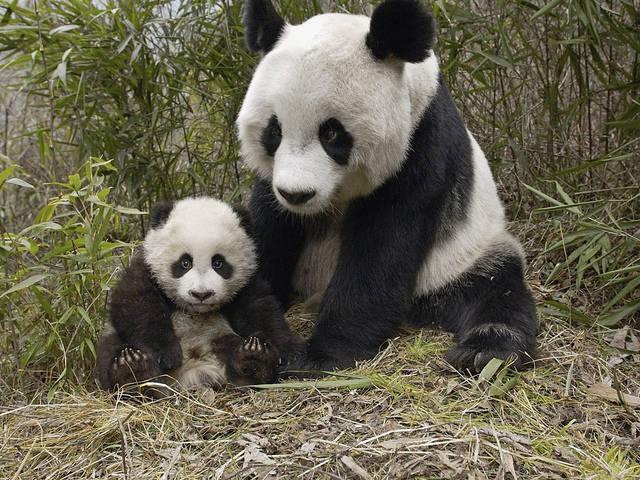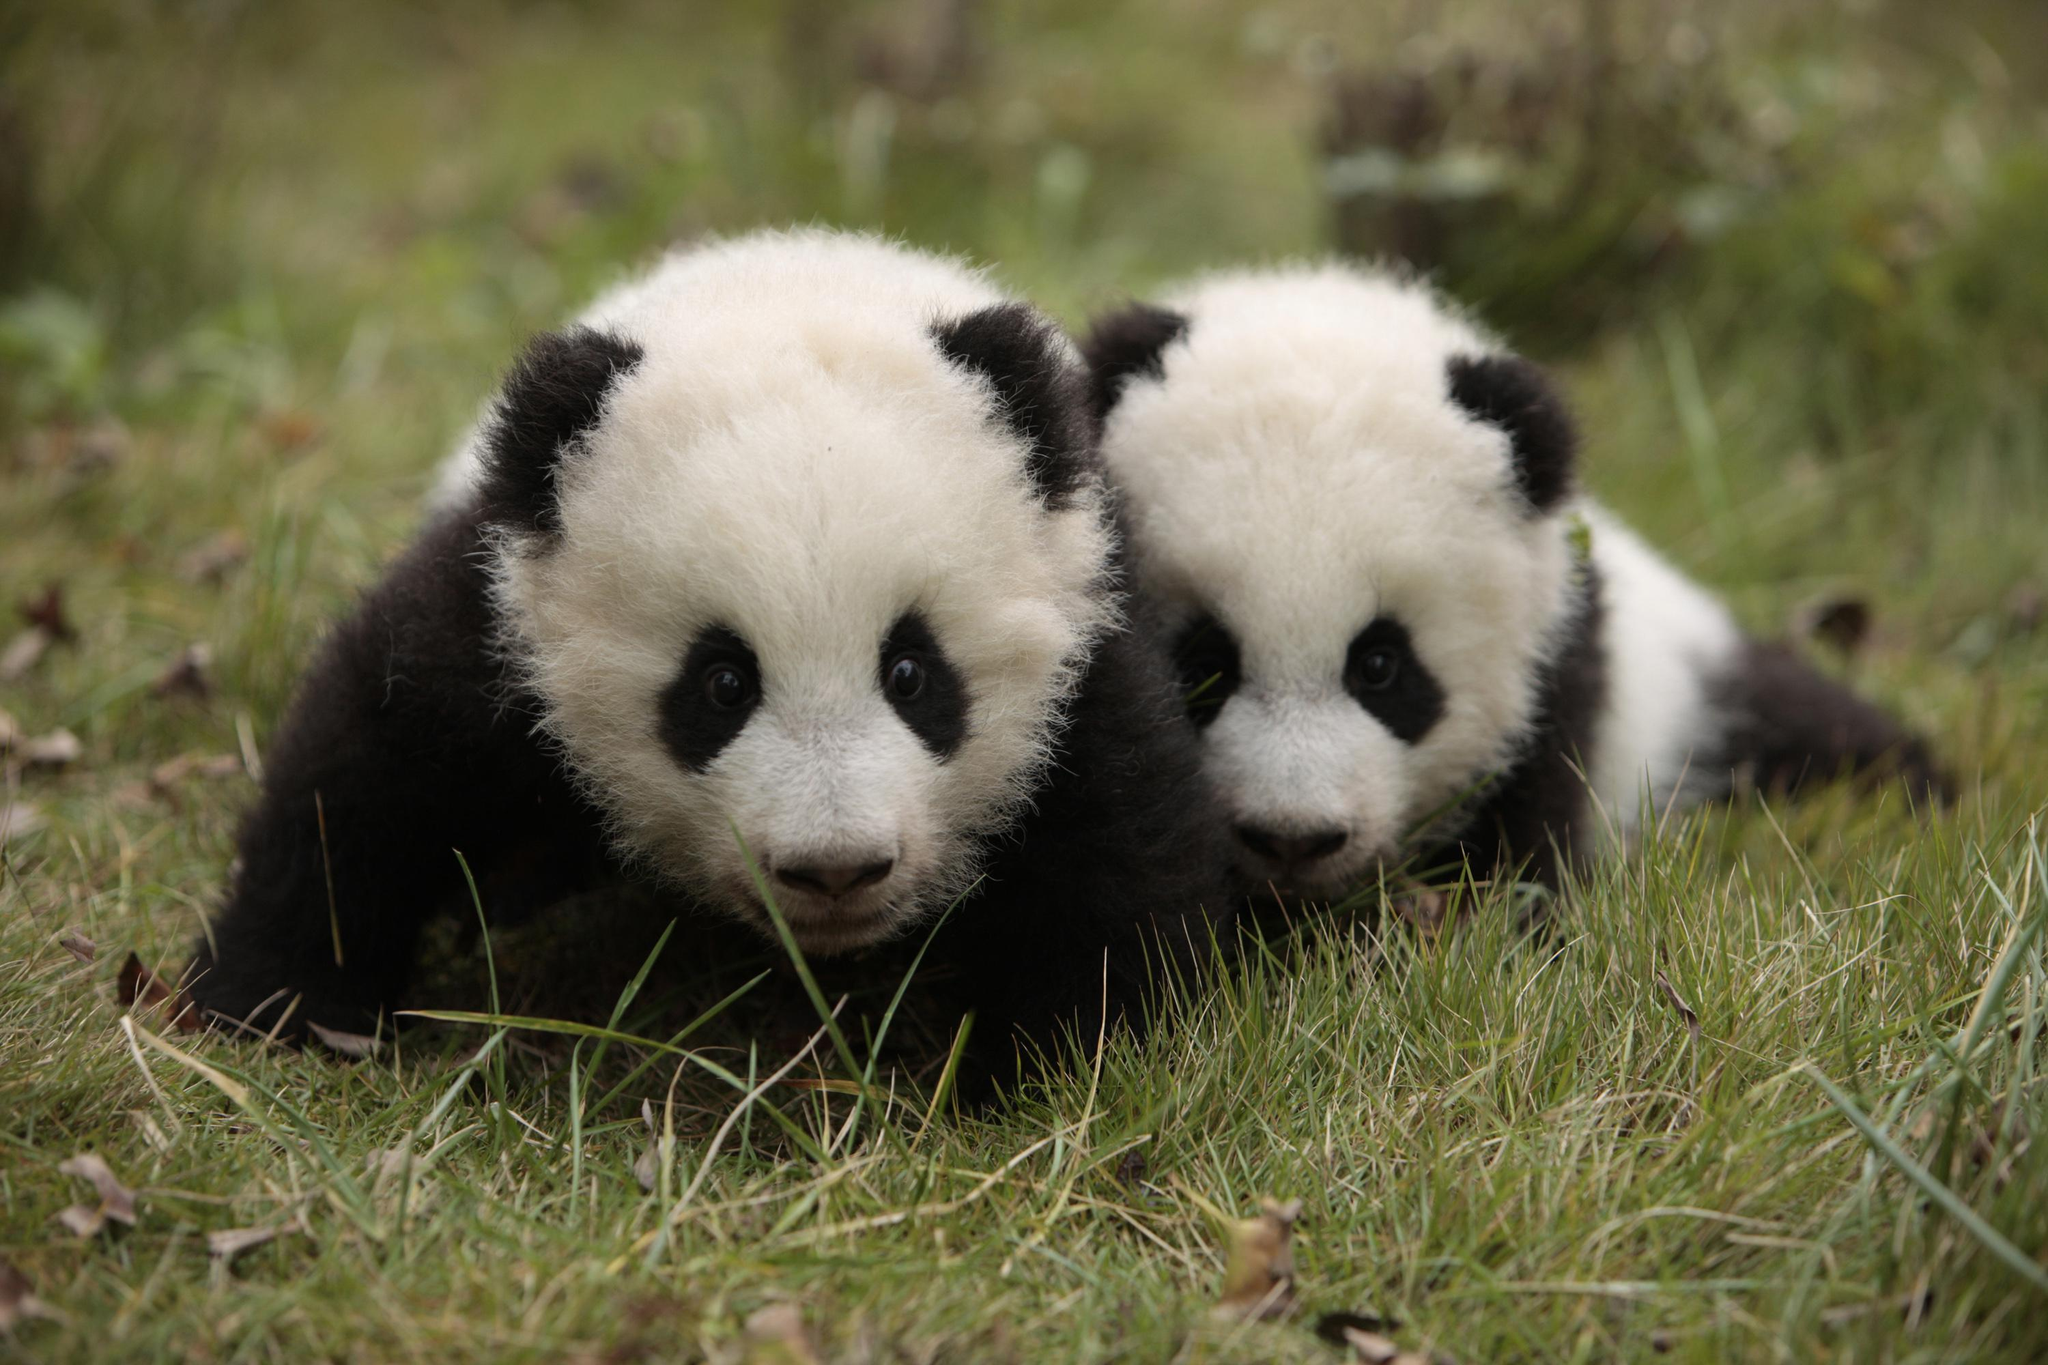The first image is the image on the left, the second image is the image on the right. Assess this claim about the two images: "There are no panda-pups in the left image.". Correct or not? Answer yes or no. No. The first image is the image on the left, the second image is the image on the right. Evaluate the accuracy of this statement regarding the images: "There is at least one baby panda on top of grass looking forward". Is it true? Answer yes or no. Yes. 